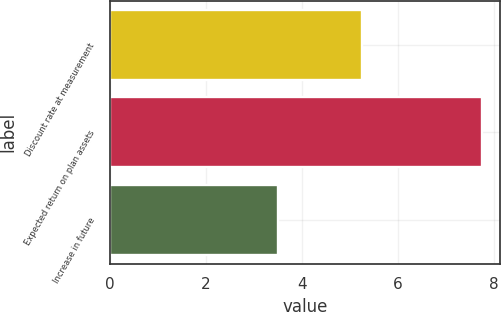Convert chart to OTSL. <chart><loc_0><loc_0><loc_500><loc_500><bar_chart><fcel>Discount rate at measurement<fcel>Expected return on plan assets<fcel>Increase in future<nl><fcel>5.25<fcel>7.75<fcel>3.5<nl></chart> 